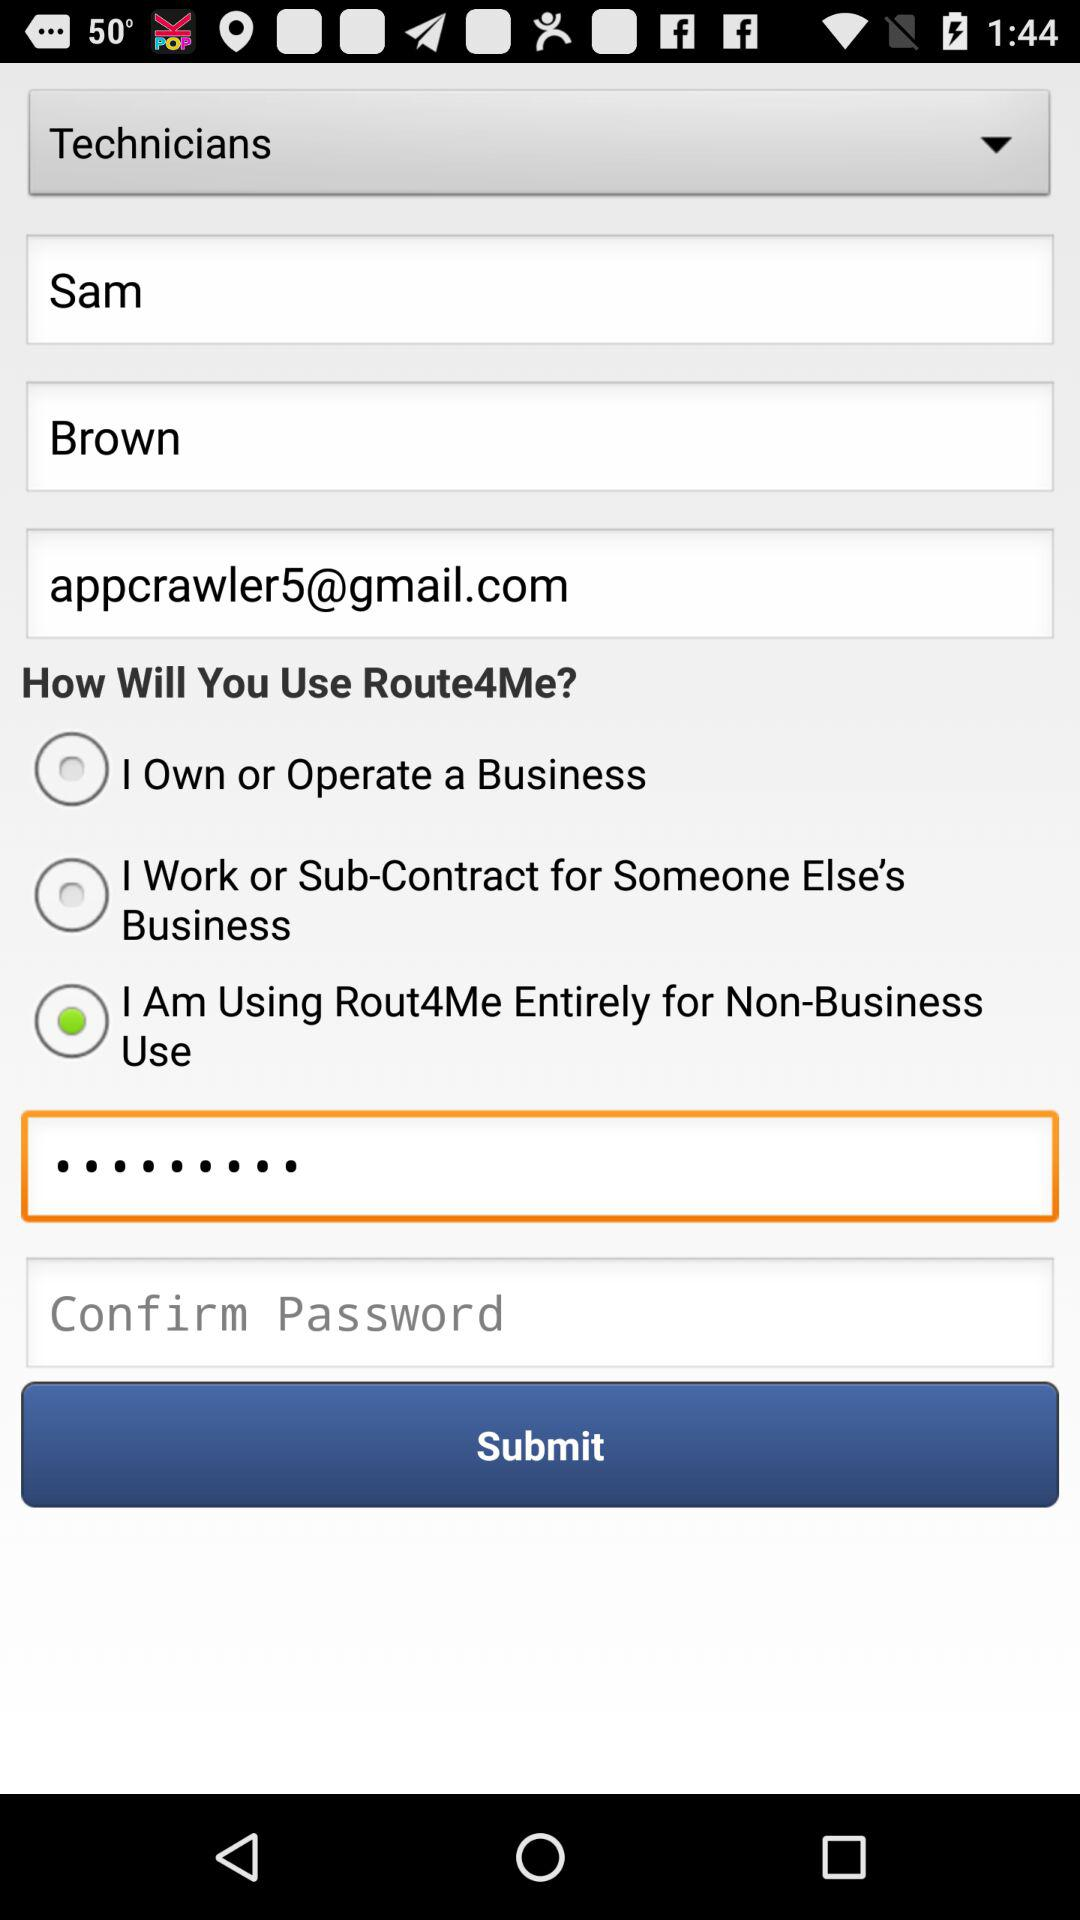What is the first name of the user? The first name of the user is Sam. 